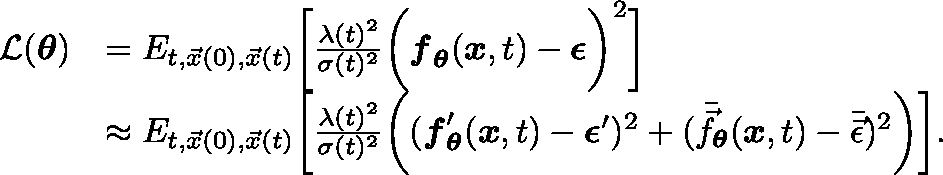Convert formula to latex. <formula><loc_0><loc_0><loc_500><loc_500>\begin{array} { r l } { \mathcal { L } ( \theta ) } & { = \mathbb { E } _ { t , \vec { x } ( 0 ) , \vec { x } ( t ) } \left [ \frac { \lambda ( t ) ^ { 2 } } { \sigma ( t ) ^ { 2 } } \left ( f _ { \theta } ( x , t ) - \epsilon \right ) ^ { 2 } \right ] } \\ & { \approx \mathbb { E } _ { t , \vec { x } ( 0 ) , \vec { x } ( t ) } \left [ \frac { \lambda ( t ) ^ { 2 } } { \sigma ( t ) ^ { 2 } } \left ( ( f _ { \theta } ^ { \prime } ( x , t ) - \epsilon ^ { \prime } ) ^ { 2 } + ( \bar { \vec { f } } _ { \theta } ( x , t ) - \bar { \vec { \epsilon } } ) ^ { 2 } \right ) \right ] . } \end{array}</formula> 